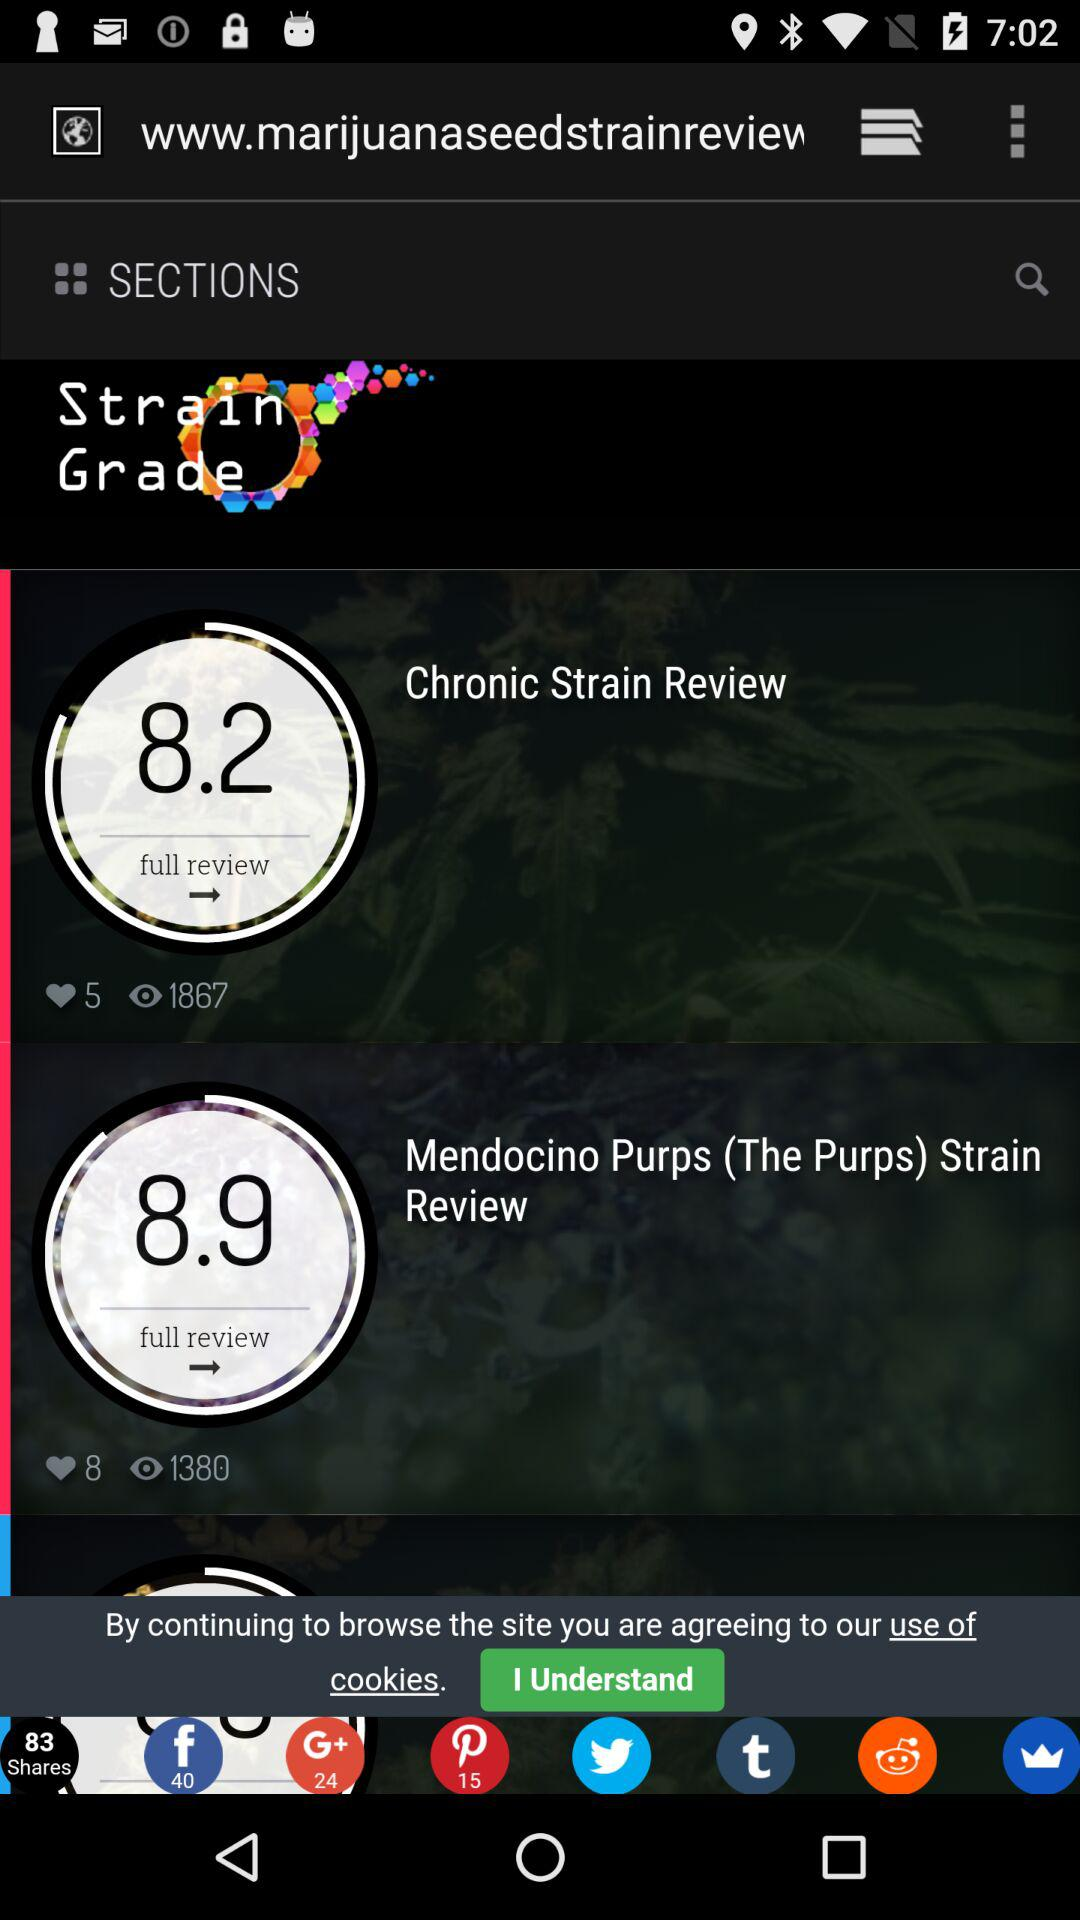What is the number of views of the chronic strain review? The number of views is 1867. 